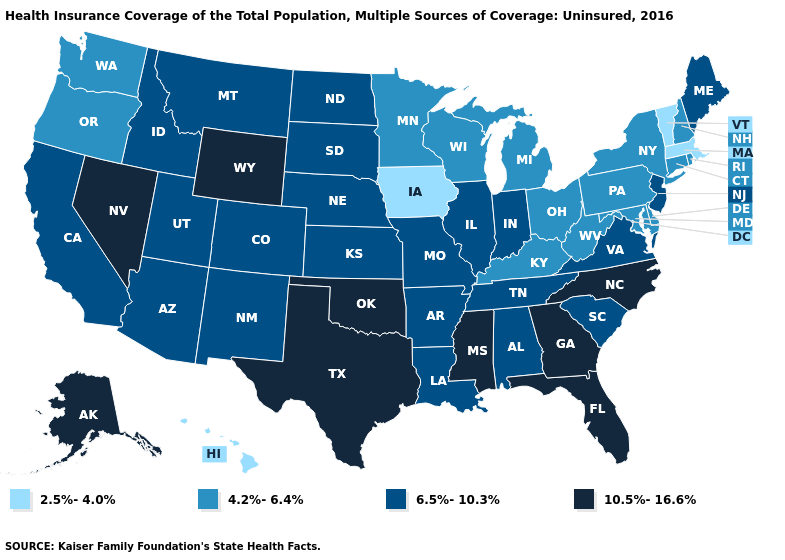Which states hav the highest value in the South?
Concise answer only. Florida, Georgia, Mississippi, North Carolina, Oklahoma, Texas. Does South Carolina have a lower value than Nevada?
Quick response, please. Yes. What is the value of Rhode Island?
Be succinct. 4.2%-6.4%. Does Delaware have the same value as New Hampshire?
Answer briefly. Yes. What is the value of Wisconsin?
Keep it brief. 4.2%-6.4%. What is the lowest value in the MidWest?
Quick response, please. 2.5%-4.0%. What is the value of New Jersey?
Write a very short answer. 6.5%-10.3%. Does the map have missing data?
Quick response, please. No. Name the states that have a value in the range 6.5%-10.3%?
Short answer required. Alabama, Arizona, Arkansas, California, Colorado, Idaho, Illinois, Indiana, Kansas, Louisiana, Maine, Missouri, Montana, Nebraska, New Jersey, New Mexico, North Dakota, South Carolina, South Dakota, Tennessee, Utah, Virginia. Does Kentucky have the lowest value in the South?
Give a very brief answer. Yes. Name the states that have a value in the range 10.5%-16.6%?
Concise answer only. Alaska, Florida, Georgia, Mississippi, Nevada, North Carolina, Oklahoma, Texas, Wyoming. What is the highest value in the USA?
Be succinct. 10.5%-16.6%. Among the states that border Kentucky , which have the highest value?
Give a very brief answer. Illinois, Indiana, Missouri, Tennessee, Virginia. What is the lowest value in the Northeast?
Be succinct. 2.5%-4.0%. 